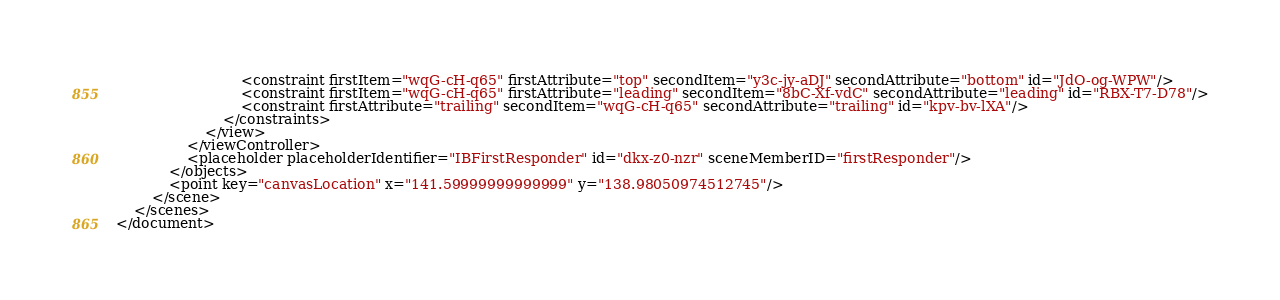<code> <loc_0><loc_0><loc_500><loc_500><_XML_>                            <constraint firstItem="wqG-cH-q65" firstAttribute="top" secondItem="y3c-jy-aDJ" secondAttribute="bottom" id="JdO-og-WPW"/>
                            <constraint firstItem="wqG-cH-q65" firstAttribute="leading" secondItem="8bC-Xf-vdC" secondAttribute="leading" id="RBX-T7-D78"/>
                            <constraint firstAttribute="trailing" secondItem="wqG-cH-q65" secondAttribute="trailing" id="kpv-bv-lXA"/>
                        </constraints>
                    </view>
                </viewController>
                <placeholder placeholderIdentifier="IBFirstResponder" id="dkx-z0-nzr" sceneMemberID="firstResponder"/>
            </objects>
            <point key="canvasLocation" x="141.59999999999999" y="138.98050974512745"/>
        </scene>
    </scenes>
</document>
</code> 